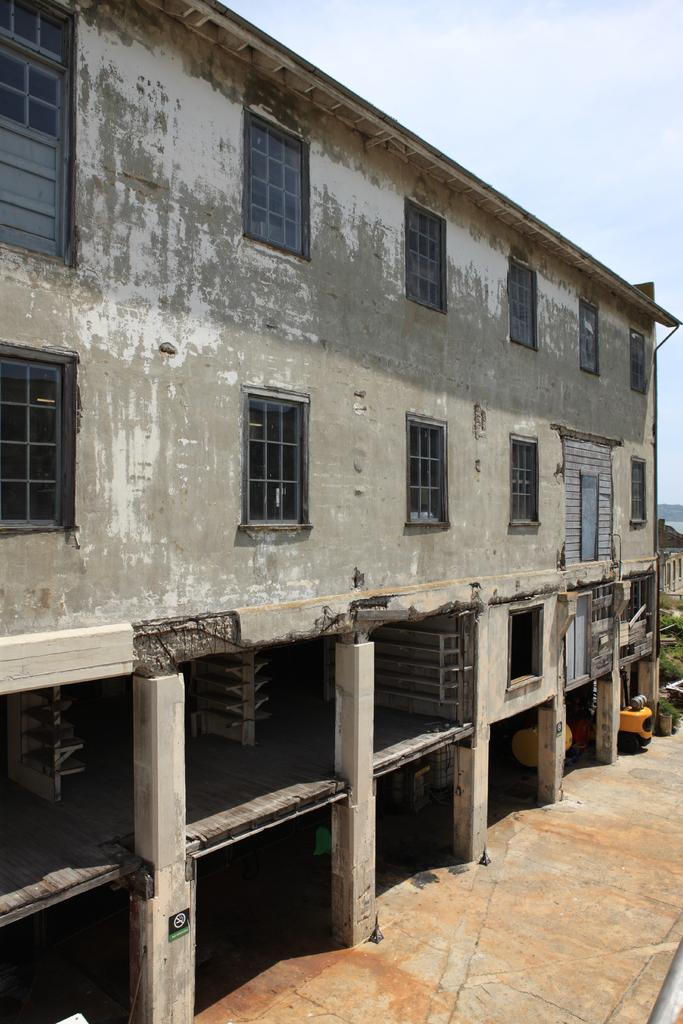What type of structure is present in the image? There is a building in the image. What can be seen beneath the building? There is ground visible in the image. What is located on the ground in the image? There are objects on the ground. What type of vegetation is present in the image? There is grass in the image. What color is one of the objects in the image? There is a yellow colored object in the image. What is visible above the building and objects? The sky is visible in the image. What type of party is being held in the image? There is no party present in the image; it features a building, ground, objects, grass, and the sky. How does the self interact with the building in the image? There is no self present in the image, as it only features a building, ground, objects, grass, and the sky. 